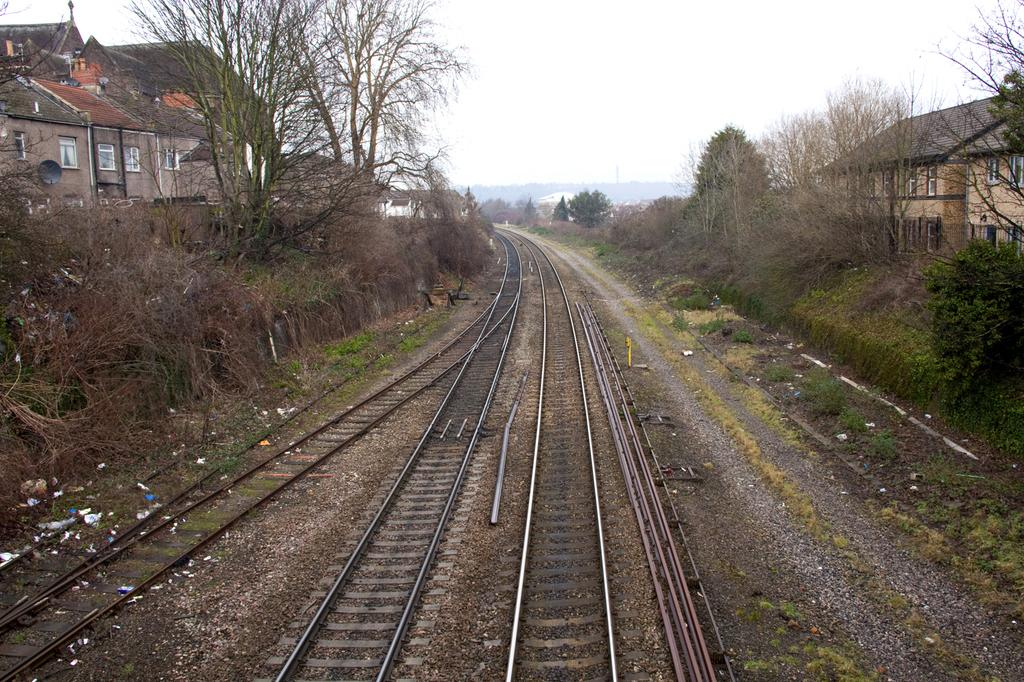What is the main feature of the image? The main feature of the image is the railway tracks. What can be seen on either side of the railway tracks? There are trees and buildings on either side of the railway tracks. Are there any other trees visible in the image? Yes, there are additional trees in the background of the image. What type of grain is being harvested in the image? There is no grain being harvested in the image; it features railway tracks with trees and buildings on either side. What activity is taking place in the image? The image does not depict any specific activity; it simply shows railway tracks with trees and buildings on either side. 